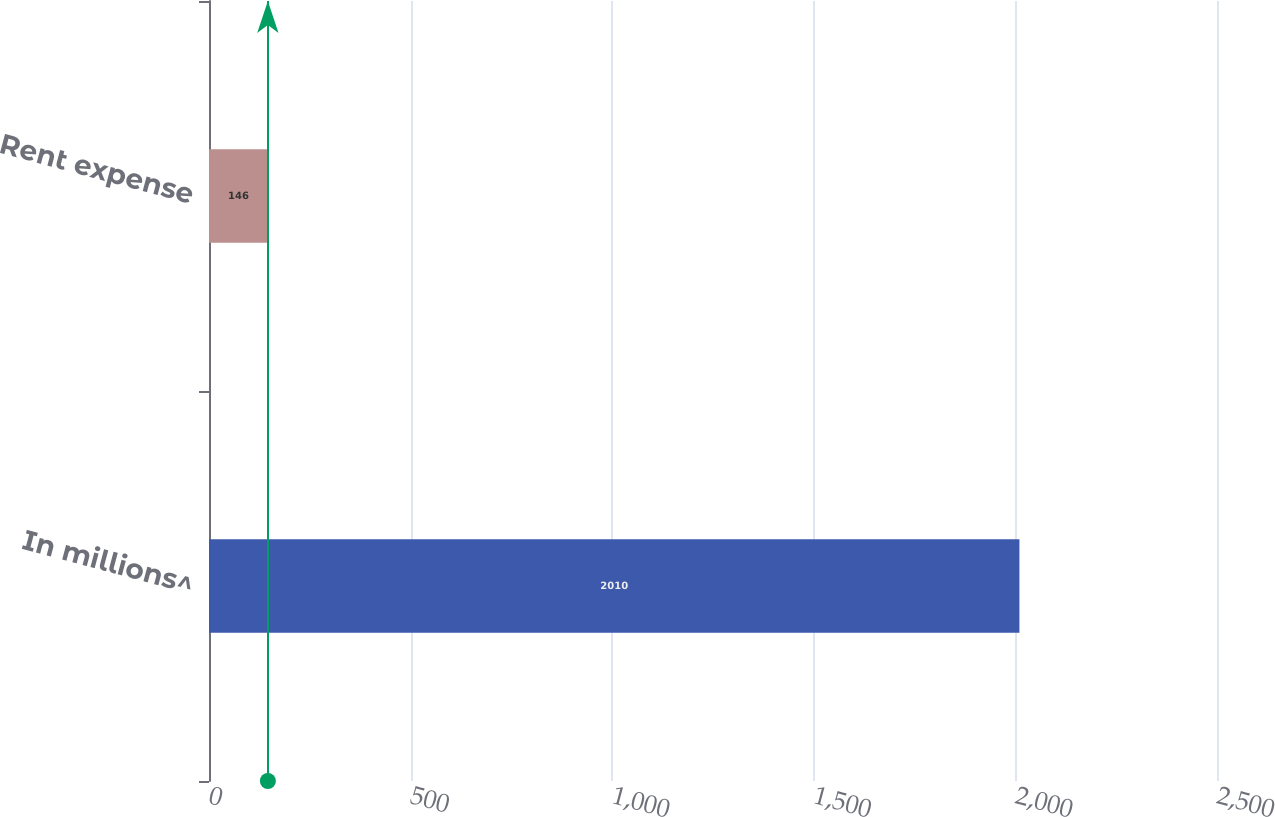Convert chart. <chart><loc_0><loc_0><loc_500><loc_500><bar_chart><fcel>In millions^<fcel>Rent expense<nl><fcel>2010<fcel>146<nl></chart> 